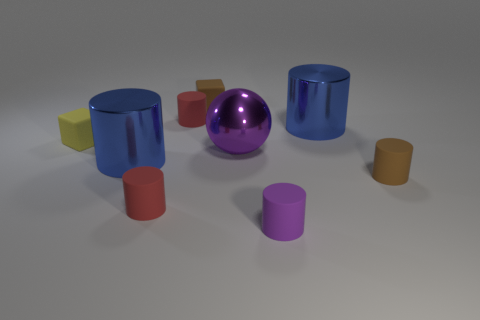Subtract 1 cylinders. How many cylinders are left? 5 Subtract all brown rubber cylinders. How many cylinders are left? 5 Subtract all brown cylinders. How many cylinders are left? 5 Add 1 small rubber blocks. How many objects exist? 10 Subtract all brown cylinders. Subtract all cyan balls. How many cylinders are left? 5 Subtract all balls. How many objects are left? 8 Add 5 yellow blocks. How many yellow blocks are left? 6 Add 8 large purple metal things. How many large purple metal things exist? 9 Subtract 0 brown balls. How many objects are left? 9 Subtract all yellow rubber things. Subtract all small objects. How many objects are left? 2 